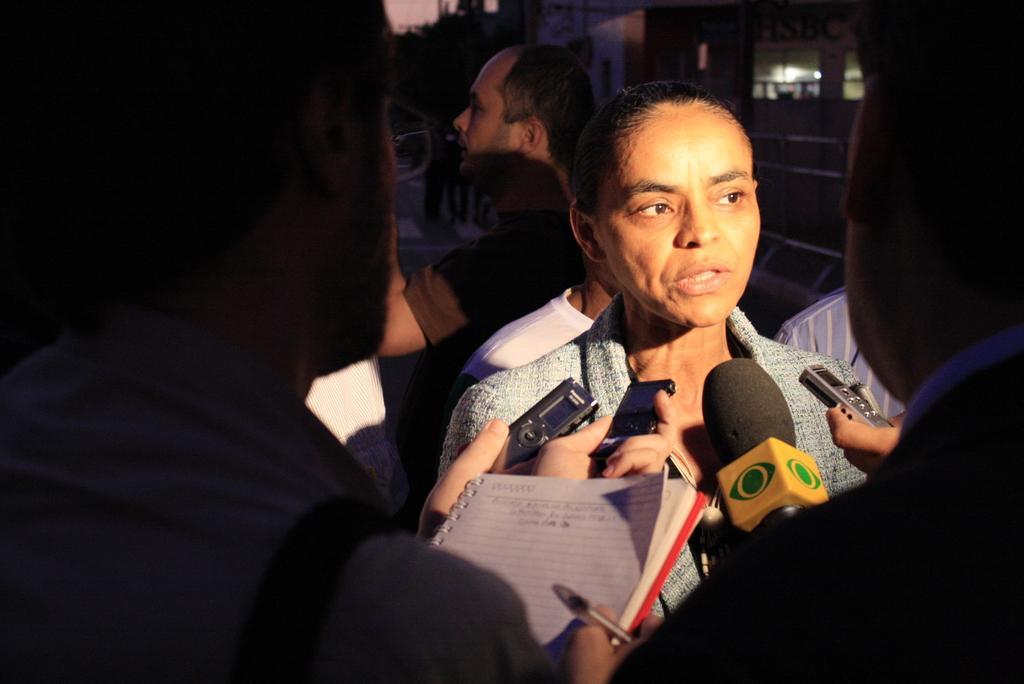Could you give a brief overview of what you see in this image? In this picture there is a woman who is wearing jacket. In front of her we can see two persons are holding a mic, mobile phone and the microphone. This person is holding a pen & book. In the background there is a cameraman who is holding a camera, standing near the window.. At the top we can see the sky, tree and electric poles. 